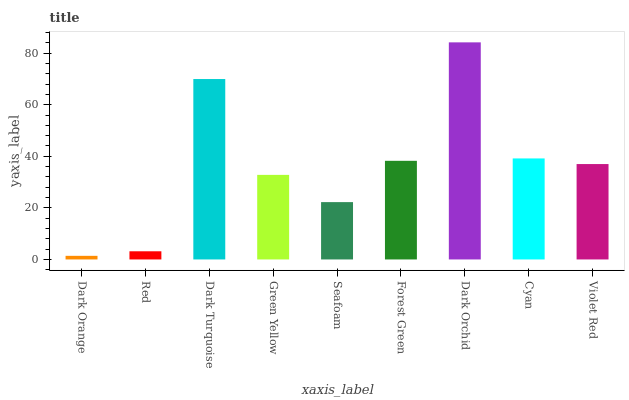Is Red the minimum?
Answer yes or no. No. Is Red the maximum?
Answer yes or no. No. Is Red greater than Dark Orange?
Answer yes or no. Yes. Is Dark Orange less than Red?
Answer yes or no. Yes. Is Dark Orange greater than Red?
Answer yes or no. No. Is Red less than Dark Orange?
Answer yes or no. No. Is Violet Red the high median?
Answer yes or no. Yes. Is Violet Red the low median?
Answer yes or no. Yes. Is Red the high median?
Answer yes or no. No. Is Seafoam the low median?
Answer yes or no. No. 